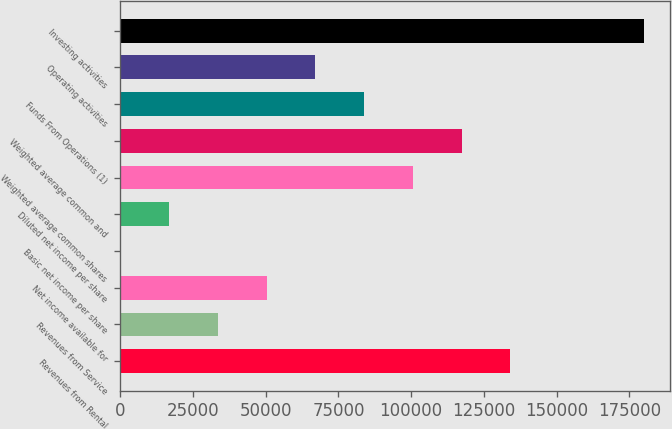Convert chart. <chart><loc_0><loc_0><loc_500><loc_500><bar_chart><fcel>Revenues from Rental<fcel>Revenues from Service<fcel>Net income available for<fcel>Basic net income per share<fcel>Diluted net income per share<fcel>Weighted average common shares<fcel>Weighted average common and<fcel>Funds From Operations (1)<fcel>Operating activities<fcel>Investing activities<nl><fcel>134096<fcel>33524.3<fcel>50286.2<fcel>0.32<fcel>16762.3<fcel>100572<fcel>117334<fcel>83810.2<fcel>67048.2<fcel>180102<nl></chart> 